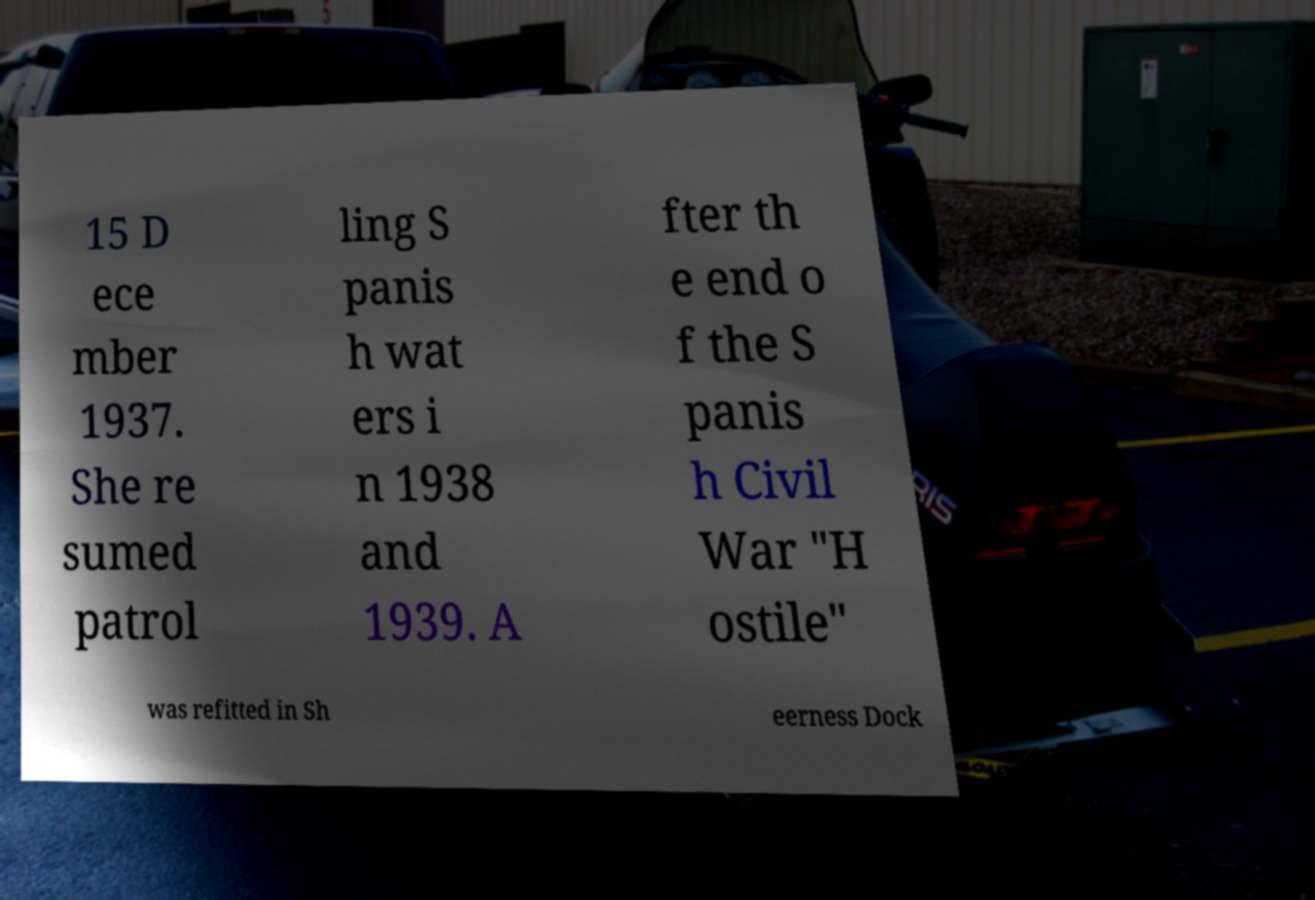Could you extract and type out the text from this image? 15 D ece mber 1937. She re sumed patrol ling S panis h wat ers i n 1938 and 1939. A fter th e end o f the S panis h Civil War "H ostile" was refitted in Sh eerness Dock 